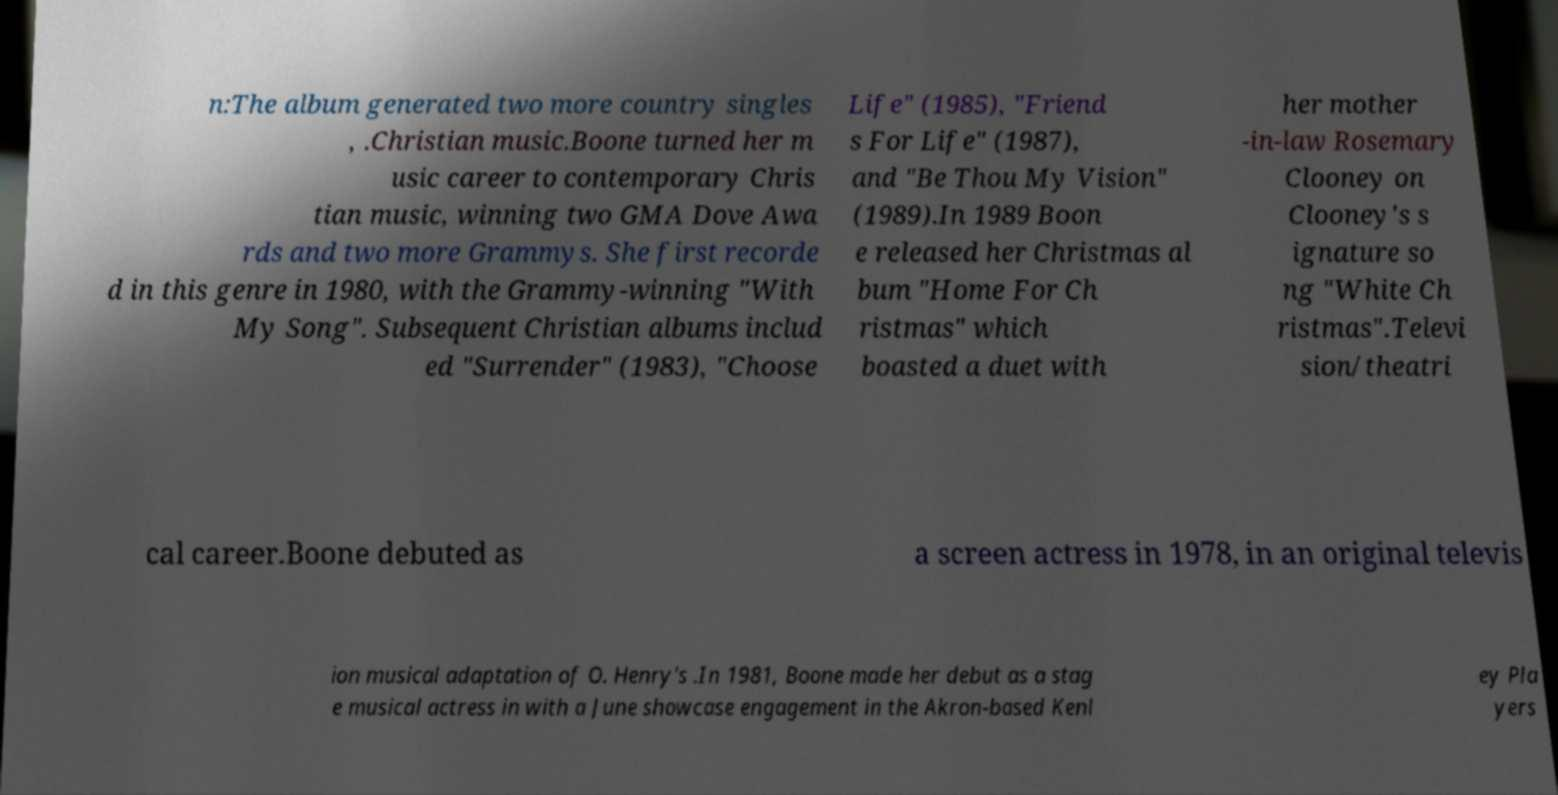What messages or text are displayed in this image? I need them in a readable, typed format. n:The album generated two more country singles , .Christian music.Boone turned her m usic career to contemporary Chris tian music, winning two GMA Dove Awa rds and two more Grammys. She first recorde d in this genre in 1980, with the Grammy-winning "With My Song". Subsequent Christian albums includ ed "Surrender" (1983), "Choose Life" (1985), "Friend s For Life" (1987), and "Be Thou My Vision" (1989).In 1989 Boon e released her Christmas al bum "Home For Ch ristmas" which boasted a duet with her mother -in-law Rosemary Clooney on Clooney's s ignature so ng "White Ch ristmas".Televi sion/theatri cal career.Boone debuted as a screen actress in 1978, in an original televis ion musical adaptation of O. Henry's .In 1981, Boone made her debut as a stag e musical actress in with a June showcase engagement in the Akron-based Kenl ey Pla yers 